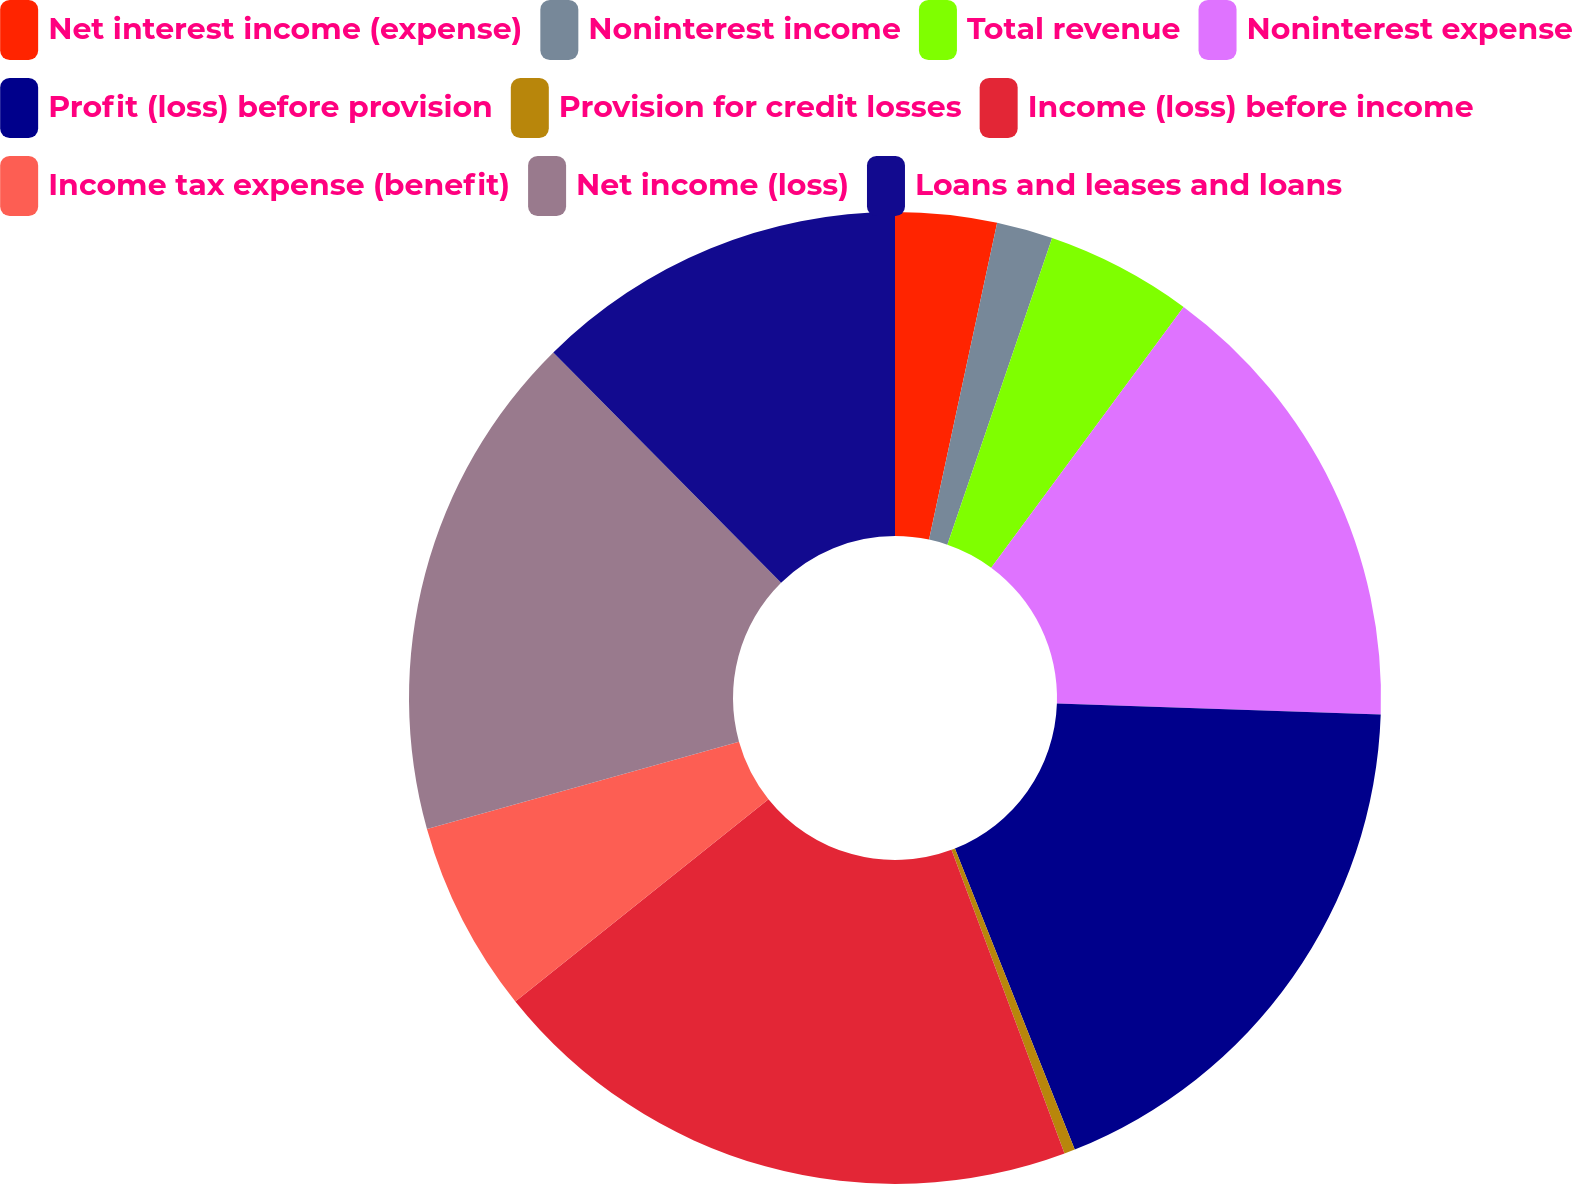<chart> <loc_0><loc_0><loc_500><loc_500><pie_chart><fcel>Net interest income (expense)<fcel>Noninterest income<fcel>Total revenue<fcel>Noninterest expense<fcel>Profit (loss) before provision<fcel>Provision for credit losses<fcel>Income (loss) before income<fcel>Income tax expense (benefit)<fcel>Net income (loss)<fcel>Loans and leases and loans<nl><fcel>3.37%<fcel>1.87%<fcel>4.88%<fcel>15.42%<fcel>18.43%<fcel>0.36%<fcel>19.94%<fcel>6.39%<fcel>16.93%<fcel>12.41%<nl></chart> 